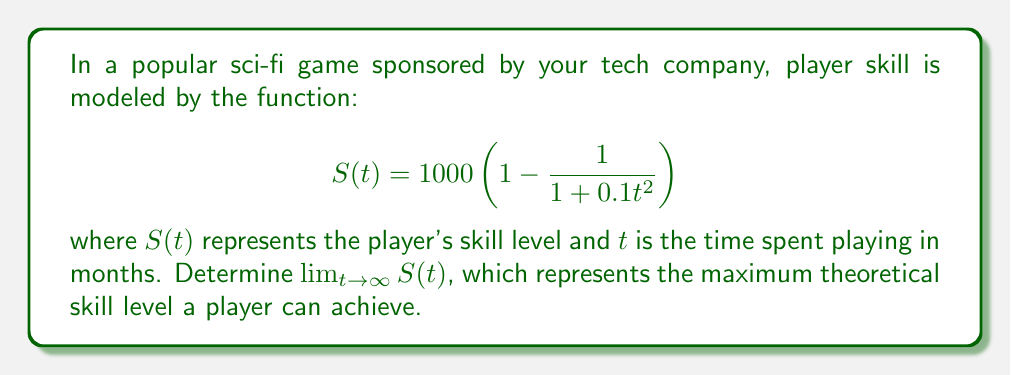Could you help me with this problem? To solve this problem, we'll follow these steps:

1) First, let's examine the structure of the function:
   $$S(t) = 1000 \left(1 - \frac{1}{1 + 0.1t^2}\right)$$

2) As $t$ approaches infinity, we need to determine what happens to the fraction $\frac{1}{1 + 0.1t^2}$.

3) Notice that as $t$ grows larger, $0.1t^2$ becomes very large. So, $1 + 0.1t^2$ also becomes very large.

4) When the denominator of a fraction grows infinitely large, the fraction itself approaches zero:

   $$\lim_{t \to \infty} \frac{1}{1 + 0.1t^2} = 0$$

5) Now, let's substitute this result back into our original function:

   $$\lim_{t \to \infty} S(t) = \lim_{t \to \infty} 1000 \left(1 - \frac{1}{1 + 0.1t^2}\right)$$
   $$= 1000 \left(1 - \lim_{t \to \infty} \frac{1}{1 + 0.1t^2}\right)$$
   $$= 1000 (1 - 0)$$
   $$= 1000$$

Therefore, the maximum theoretical skill level a player can achieve is 1000.
Answer: $\lim_{t \to \infty} S(t) = 1000$ 